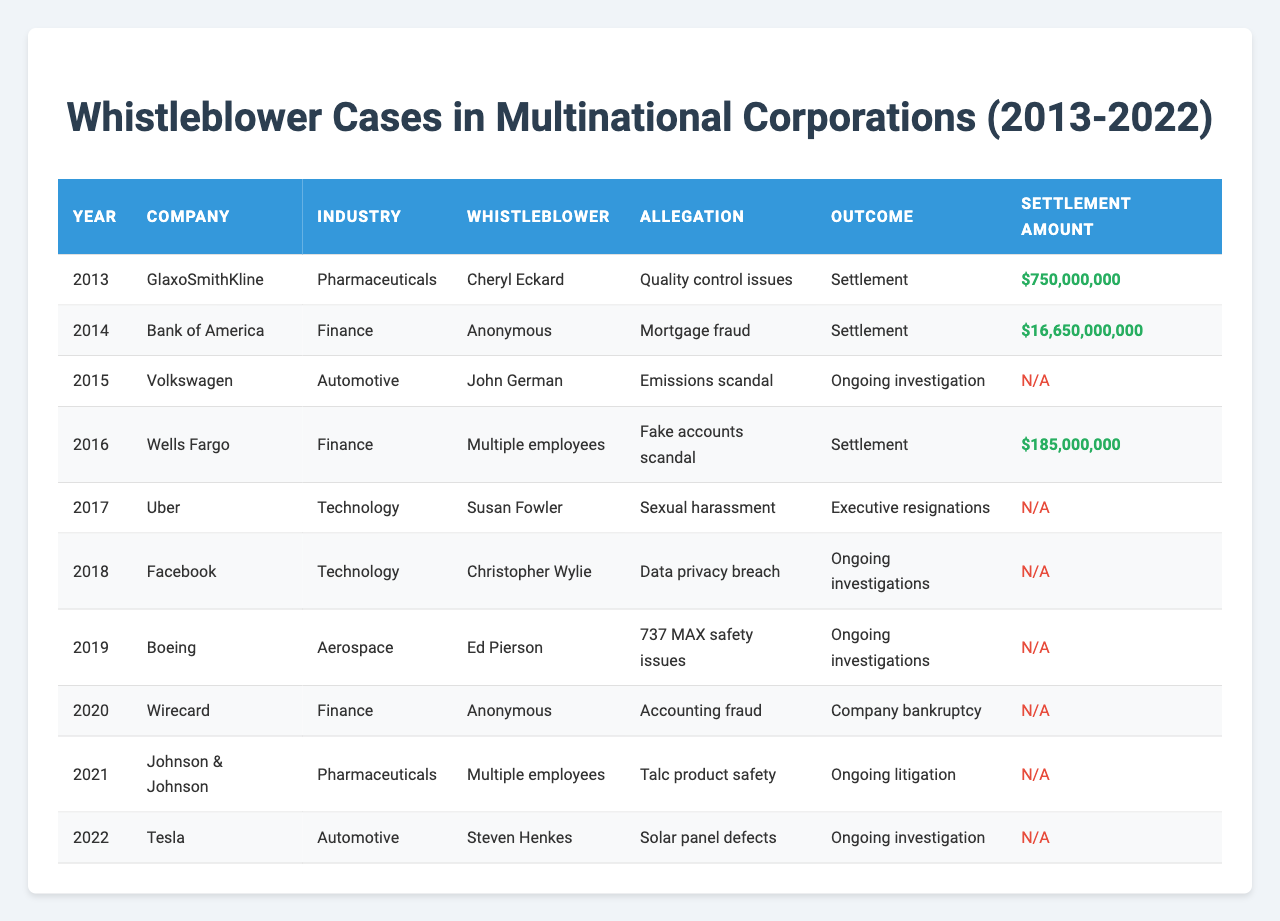What year did GlaxoSmithKline's whistleblower case occur? The table shows that the whistleblower case for GlaxoSmithKline occurred in the year 2013.
Answer: 2013 How many whistleblower cases resulted in a settlement? By reviewing the table, we see that there are three cases with a listed outcome of "Settlement." These occurred in 2013, 2014, and 2016.
Answer: 3 Which company faced a whistleblower case involving a mortgage fraud allegation? The table indicates that Bank of America faced a whistleblower case in 2014 with the allegation of "Mortgage fraud."
Answer: Bank of America What is the total settlement amount for all cases that resulted in settlements? The settlement amounts for cases that resulted in settlements are $750,000,000 (2013) + $16,650,000,000 (2014) + $185,000,000 (2016) = $17,585,000,000.
Answer: $17,585,000,000 Did any whistleblower cases lead to executive resignations? According to the table, the case involving Uber in 2017 led to "Executive resignations" as the outcome.
Answer: Yes In which industry did the whistleblower case regarding quality control issues occur? The table specifies that the case concerning quality control issues took place within the Pharmaceuticals industry, related to GlaxoSmithKline in 2013.
Answer: Pharmaceuticals What was the allegation made against Volkswagen in 2015, and what was its outcome? The allegation against Volkswagen in 2015 was "Emissions scandal," and the case is marked as "Ongoing investigation" in the table.
Answer: Emissions scandal; Ongoing investigation How many whistleblower cases involved multiple whistleblowers? Upon examining the table, we find that there are two cases where the whistleblower is listed as "Multiple employees" – for Wells Fargo in 2016 and Johnson & Johnson in 2021.
Answer: 2 What are the settlement amounts for the cases with ongoing investigations? The table shows that for ongoing investigations, there are no settlement amounts listed, so they are all marked as "N/A."
Answer: N/A Which company's whistleblower case had the highest settlement amount, and what was that amount? From the table, Bank of America had the highest settlement amount of $16,650,000,000 in 2014.
Answer: Bank of America; $16,650,000,000 Is there a whistleblower case from 2022, and what was its outcome? Yes, there is a whistleblower case from Tesla in 2022 concerning "Solar panel defects," and it states the outcome is "Ongoing investigation."
Answer: Yes; Ongoing investigation 